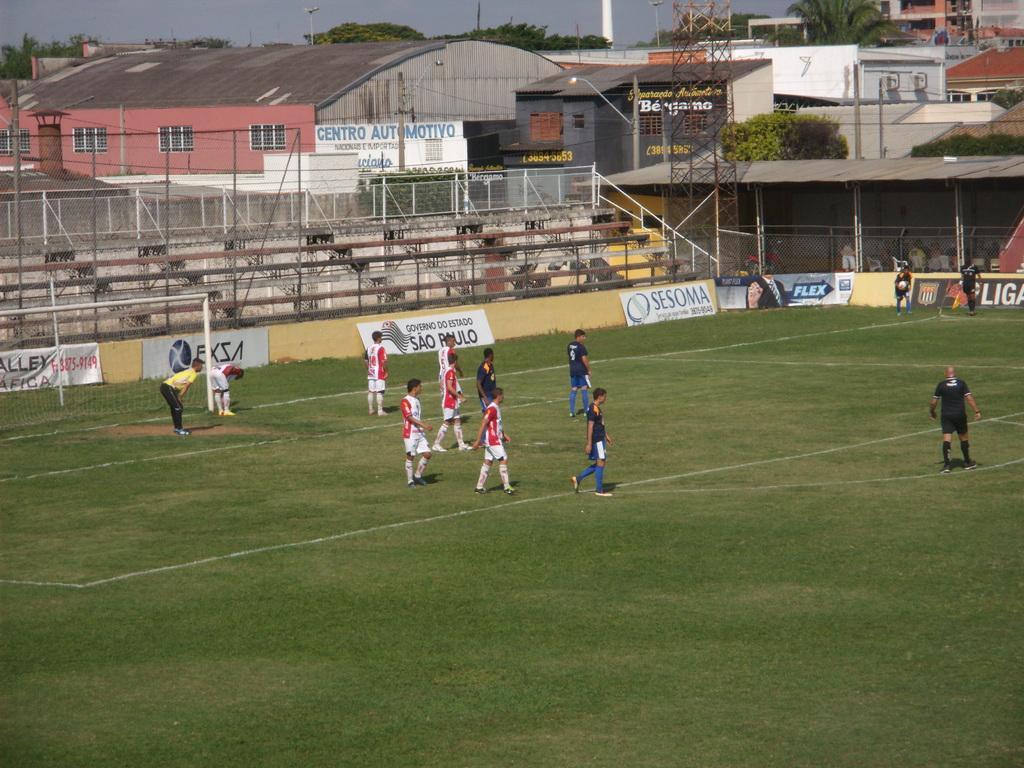Describe this image in one or two sentences. In this image it seems like it is a football match. There is a ground in the middle on which there are football players walking on it. On the left side there is a goal post. In the background there is a stadium which is covered by the fencing. In the background there are buildings with the windows. There are boarding around the ground. In between the boarding's there is a tower and there are trees in between the buildings. 